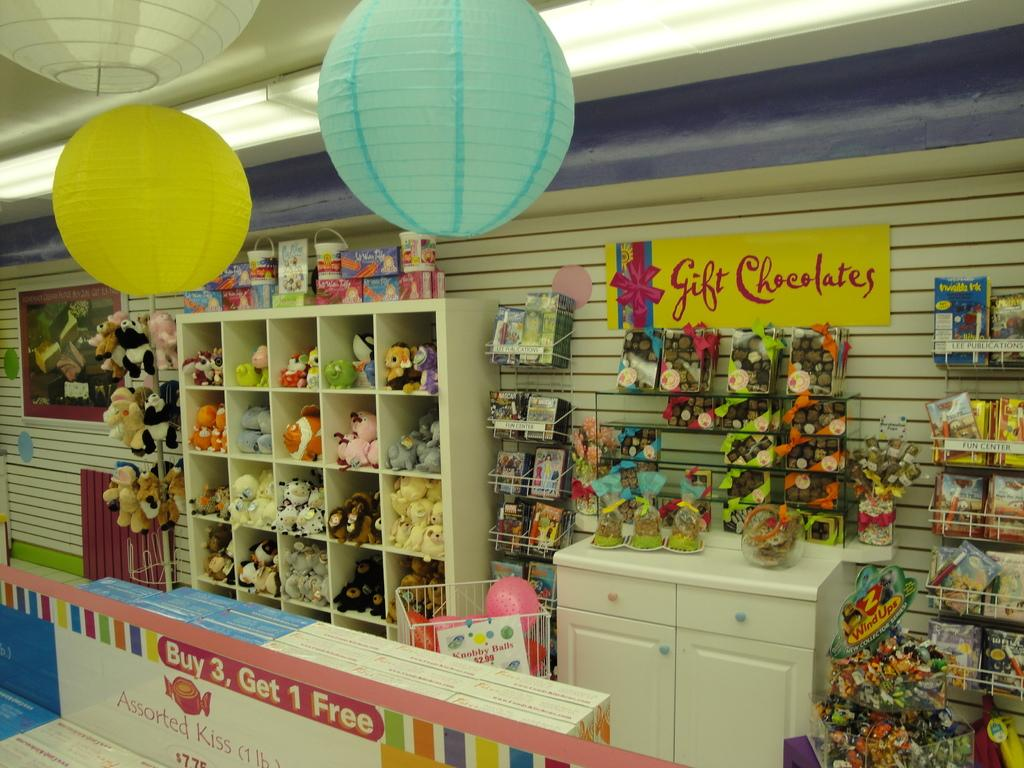<image>
Share a concise interpretation of the image provided. Assorted kiss are buy 3 get 1 free according to a sign at the counter. 